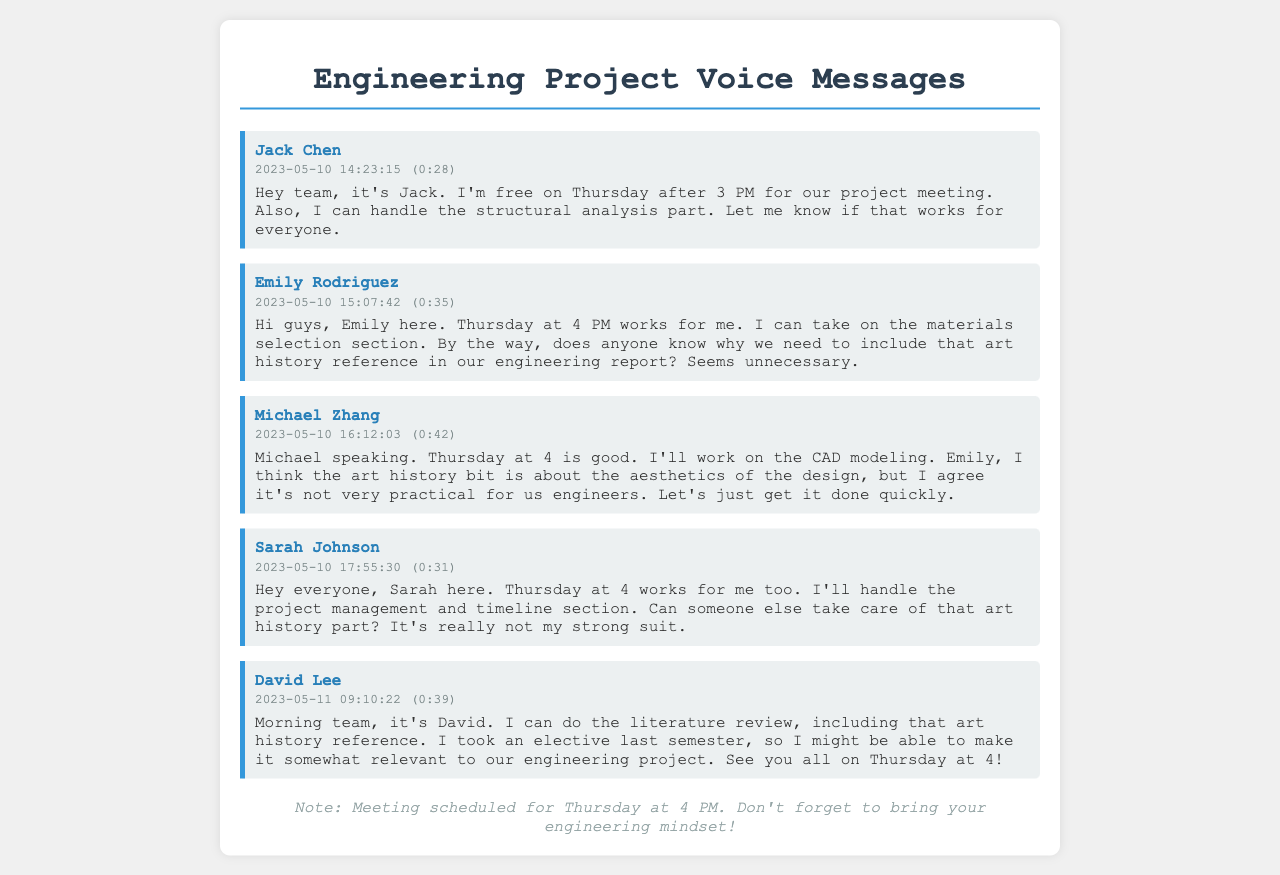What day is the meeting scheduled for? The meeting is mentioned in multiple messages with the same date noted specifically as Thursday.
Answer: Thursday Who will handle the structural analysis part? Jack Chen specified in his message that he can handle the structural analysis part of the project.
Answer: Jack Chen What time is the meeting set for? The meeting time is established as 4 PM in multiple messages.
Answer: 4 PM Who is taking care of the art history reference? David Lee volunteered to handle the literature review, including the art history reference, as stated in his message.
Answer: David Lee What section will Emily Rodriguez work on? Emily mentioned that she would take on the materials selection section in her message.
Answer: materials selection Is anyone uncertain about the art history reference's relevance? Emily Rodriguez expressed uncertainty about the necessity of including the art history reference in their engineering report.
Answer: yes What task will Sarah Johnson manage? Sarah stated she would handle the project management and timeline section in her message.
Answer: project management and timeline How long is Michael Zhang's message? Michael's message duration is indicated in the document as 42 seconds.
Answer: 0:42 